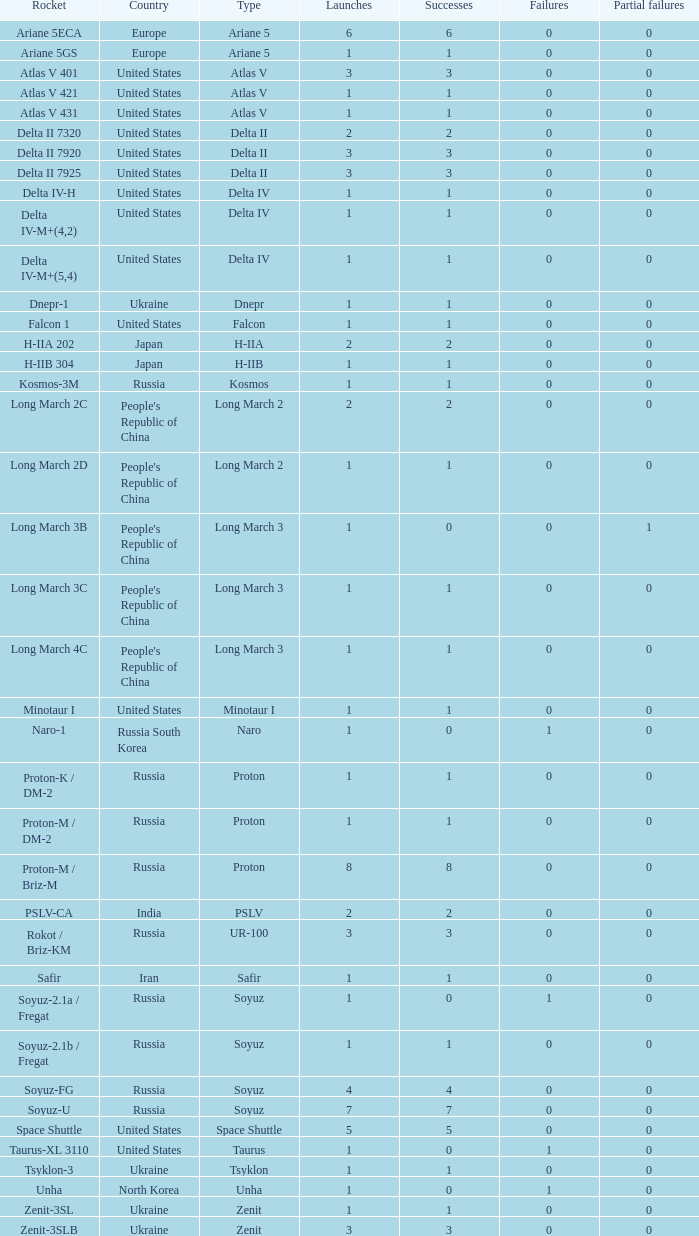For russian rockets with more than 3 launches, what is the count of successful launches for soyuz and soyuz-u rocket types? 1.0. 